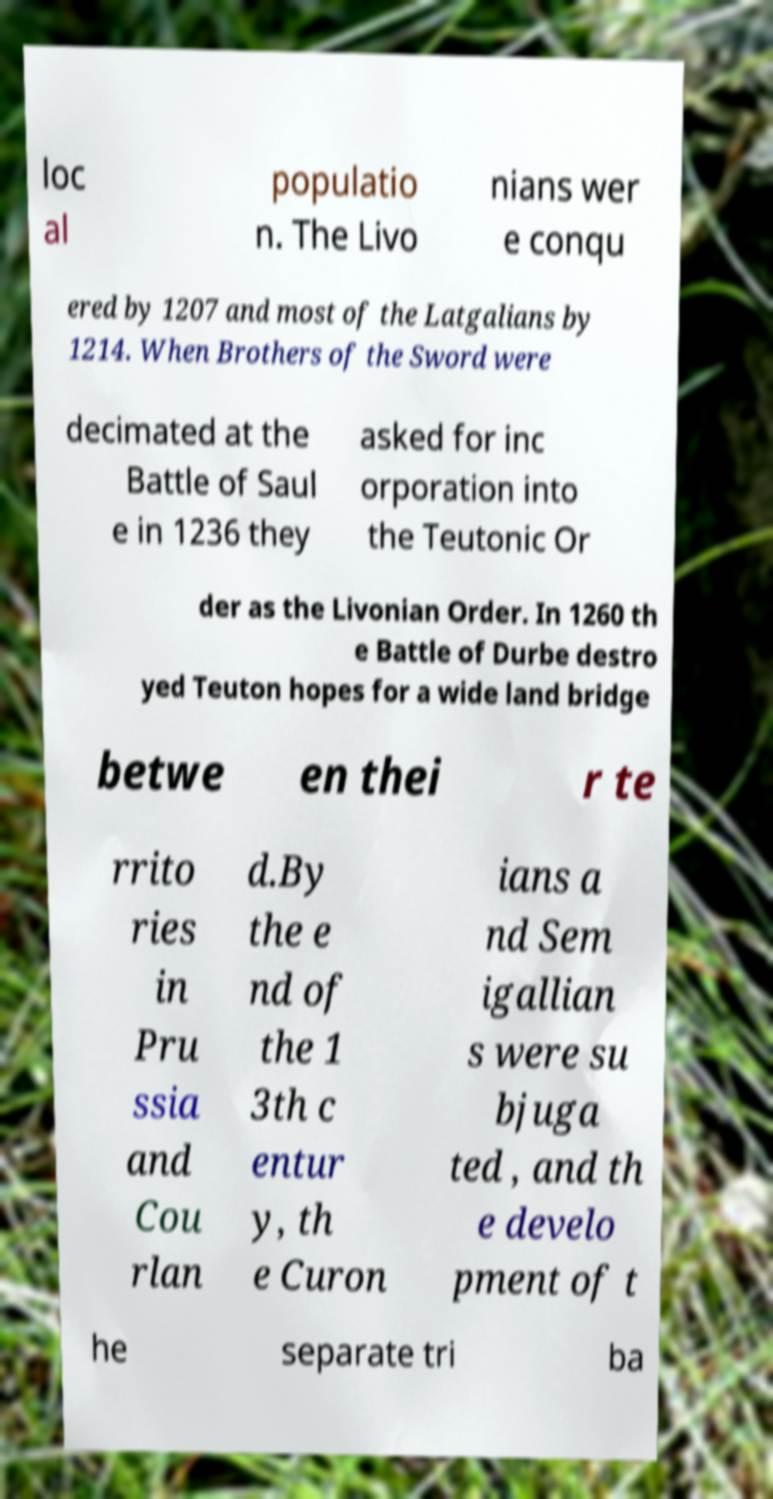Please identify and transcribe the text found in this image. loc al populatio n. The Livo nians wer e conqu ered by 1207 and most of the Latgalians by 1214. When Brothers of the Sword were decimated at the Battle of Saul e in 1236 they asked for inc orporation into the Teutonic Or der as the Livonian Order. In 1260 th e Battle of Durbe destro yed Teuton hopes for a wide land bridge betwe en thei r te rrito ries in Pru ssia and Cou rlan d.By the e nd of the 1 3th c entur y, th e Curon ians a nd Sem igallian s were su bjuga ted , and th e develo pment of t he separate tri ba 